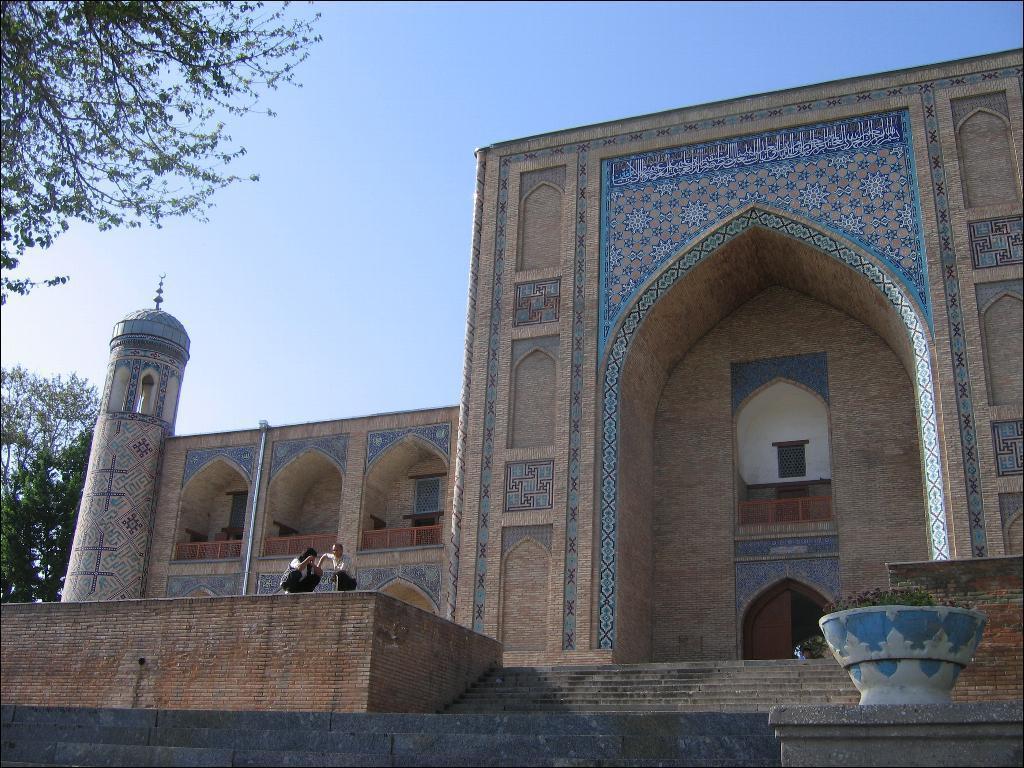How would you summarize this image in a sentence or two? In this image we can see the outside view of the monument. We can also see two persons in this image. Image also consists of trees. Sky is also visible. 